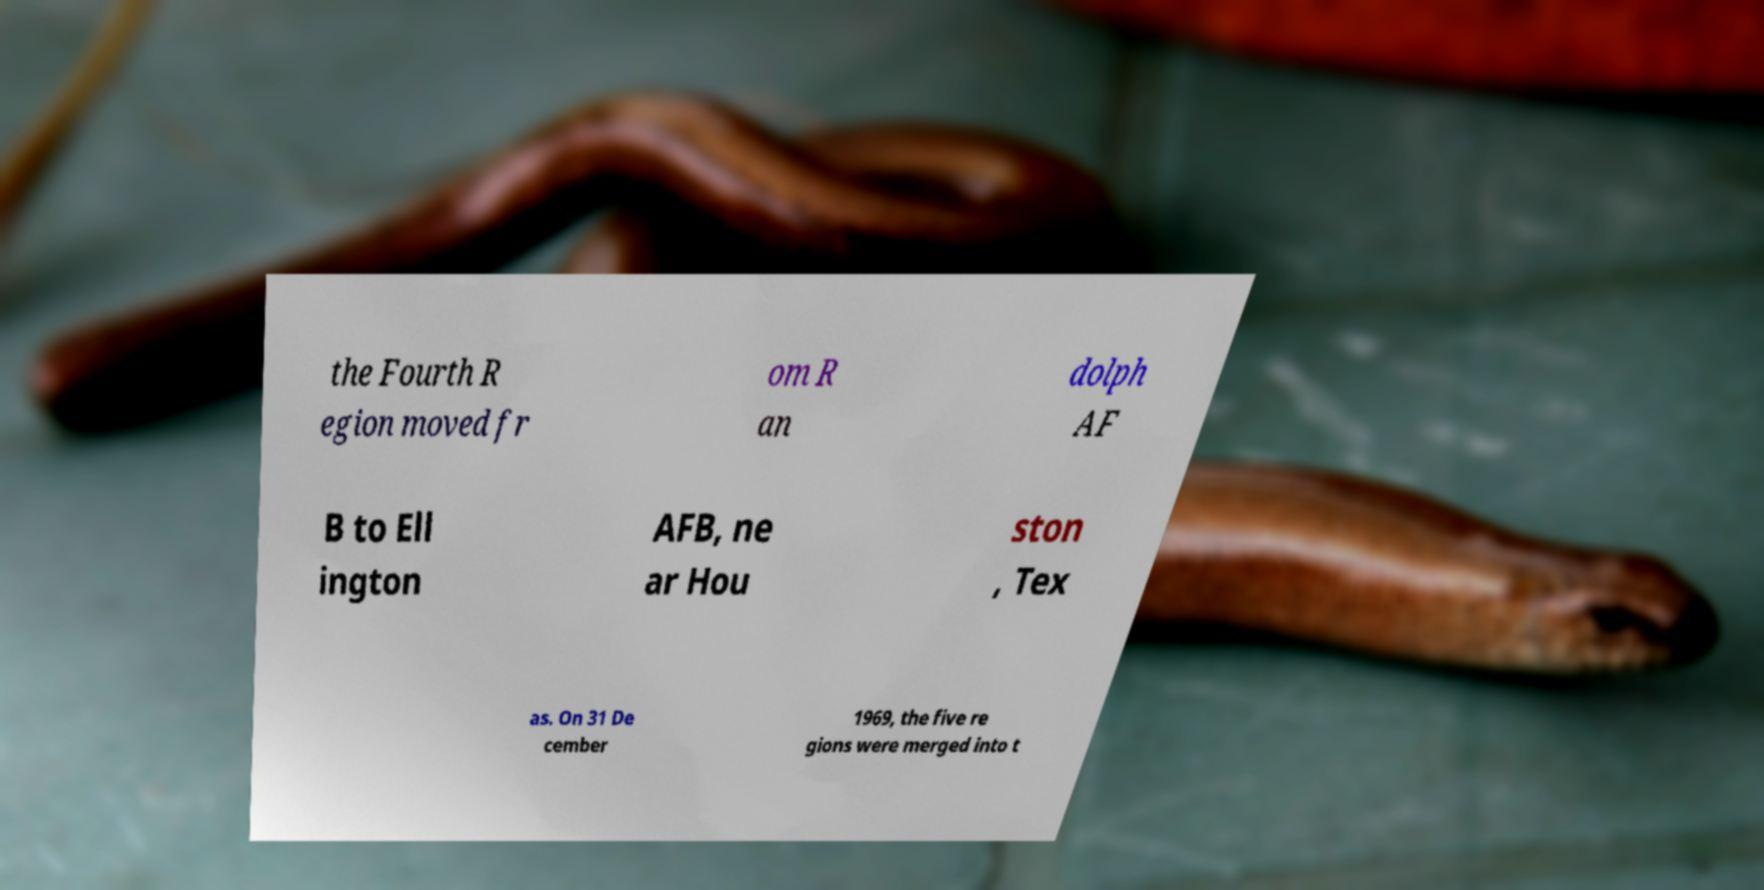Could you assist in decoding the text presented in this image and type it out clearly? the Fourth R egion moved fr om R an dolph AF B to Ell ington AFB, ne ar Hou ston , Tex as. On 31 De cember 1969, the five re gions were merged into t 